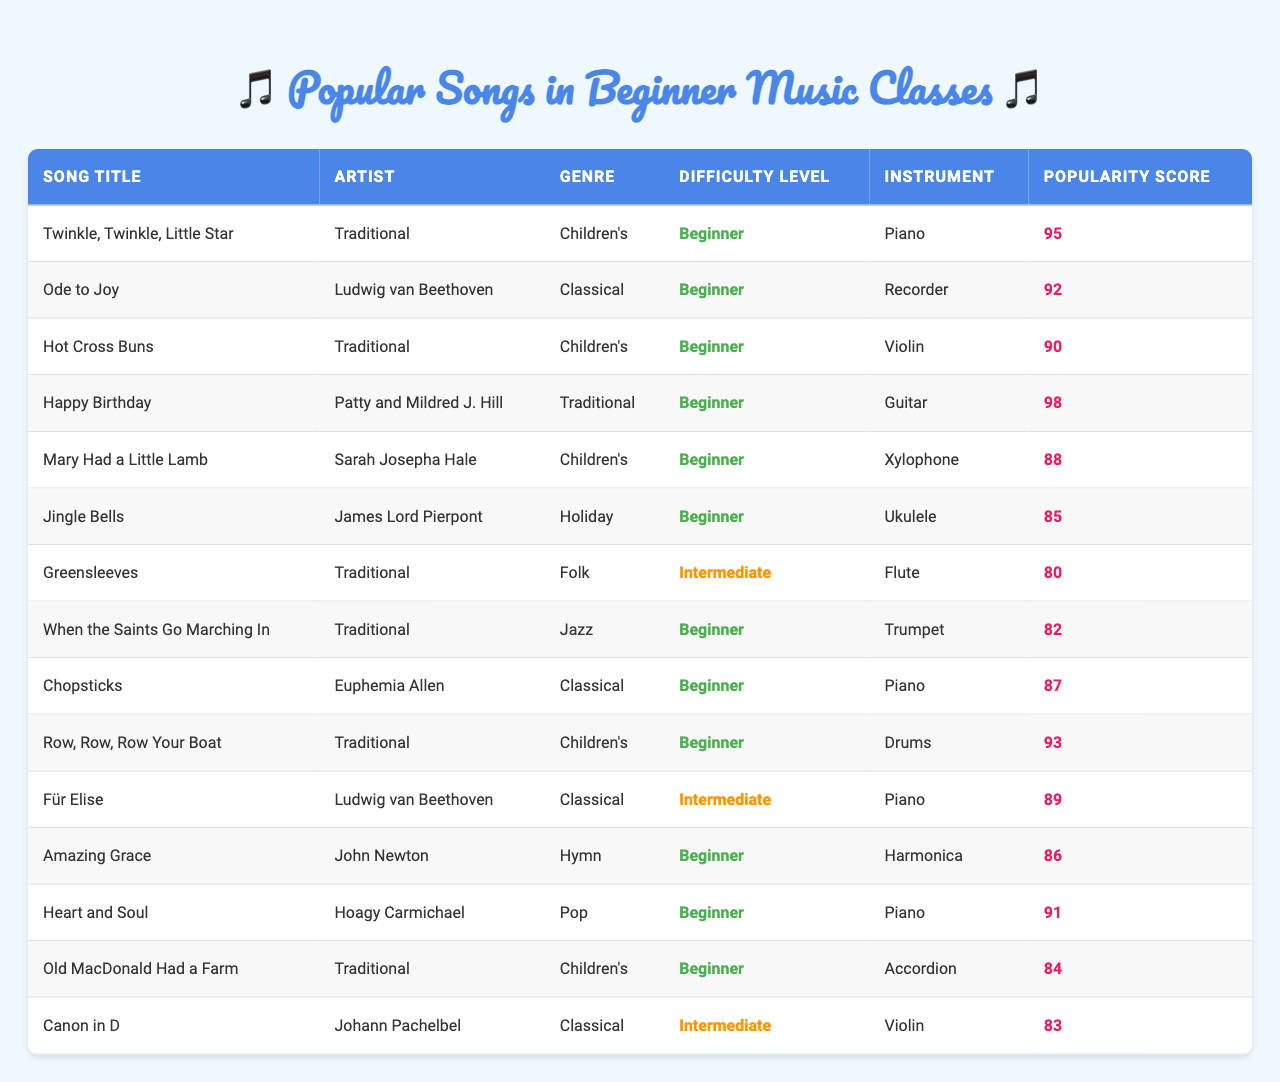What is the highest popularity score among the beginner songs? By looking at the "Popularity Score" column, the song "Happy Birthday" has the highest score of 98 among the listed beginner songs.
Answer: 98 Which instrument is used to play "Ode to Joy"? The song "Ode to Joy" is associated with the Recorder, as seen in the "Instrument" column next to the song title.
Answer: Recorder Are there any songs that are classified as both "Beginner" and "Children’s" songs? Yes, "Twinkle, Twinkle, Little Star," "Hot Cross Buns," "Mary Had a Little Lamb," and "Row, Row, Row Your Boat" are all listed as Beginner and in the Children's genre.
Answer: Yes What is the average popularity score of beginner songs played on the Piano? The beginner songs played on the Piano are "Twinkle, Twinkle, Little Star," "Chopsticks," and "Heart and Soul," with scores of 95, 87, and 91 respectively. Thus, the average is (95 + 87 + 91) / 3 = 91.
Answer: 91 How many songs are categorized as "Traditional"? Five songs are categorized as "Traditional" in the Genre column: "Twinkle, Twinkle, Little Star," "Hot Cross Buns," "Happy Birthday," "Mary Had a Little Lamb," and "Old MacDonald Had a Farm."
Answer: 5 Which song has a popularity score greater than 90, is played on the Ukulele, but not classified as a Children’s song? "Jingle Bells" fits this criteria as it has a popularity score of 85, is played on the Ukulele, but does not fall under the Children’s genre.
Answer: No song meets that criteria Is there a song that has the same artist and difficulty level as "Mary Had a Little Lamb"? "Old MacDonald Had a Farm" is another song by a Traditional artist classified as "Beginner," making it the same in that aspect compared to "Mary Had a Little Lamb."
Answer: Yes Which genre has the most songs listed in the beginner category? The Children's genre has four songs: "Twinkle, Twinkle, Little Star," "Hot Cross Buns," "Mary Had a Little Lamb," and "Row, Row, Row Your Boat," which is the most for beginners.
Answer: Children's What is the total number of beginner songs listed in the table? There are 10 songs categorized as "Beginner," counted from the data provided.
Answer: 10 Can you list the titles of all the songs that are classified as "Intermediate"? The songs classified as "Intermediate" are "Greensleeves," "Für Elise," and "Canon in D." This can be determined by checking the difficulty level in the table.
Answer: Greensleeves, Für Elise, Canon in D 